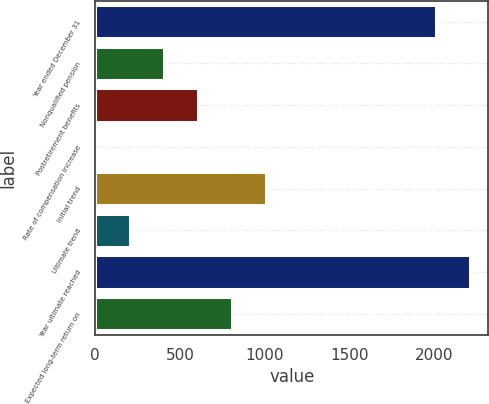Convert chart. <chart><loc_0><loc_0><loc_500><loc_500><bar_chart><fcel>Year ended December 31<fcel>Nonqualified pension<fcel>Postretirement benefits<fcel>Rate of compensation increase<fcel>Initial trend<fcel>Ultimate trend<fcel>Year ultimate reached<fcel>Expected long-term return on<nl><fcel>2010<fcel>406<fcel>607<fcel>4<fcel>1009<fcel>205<fcel>2211<fcel>808<nl></chart> 